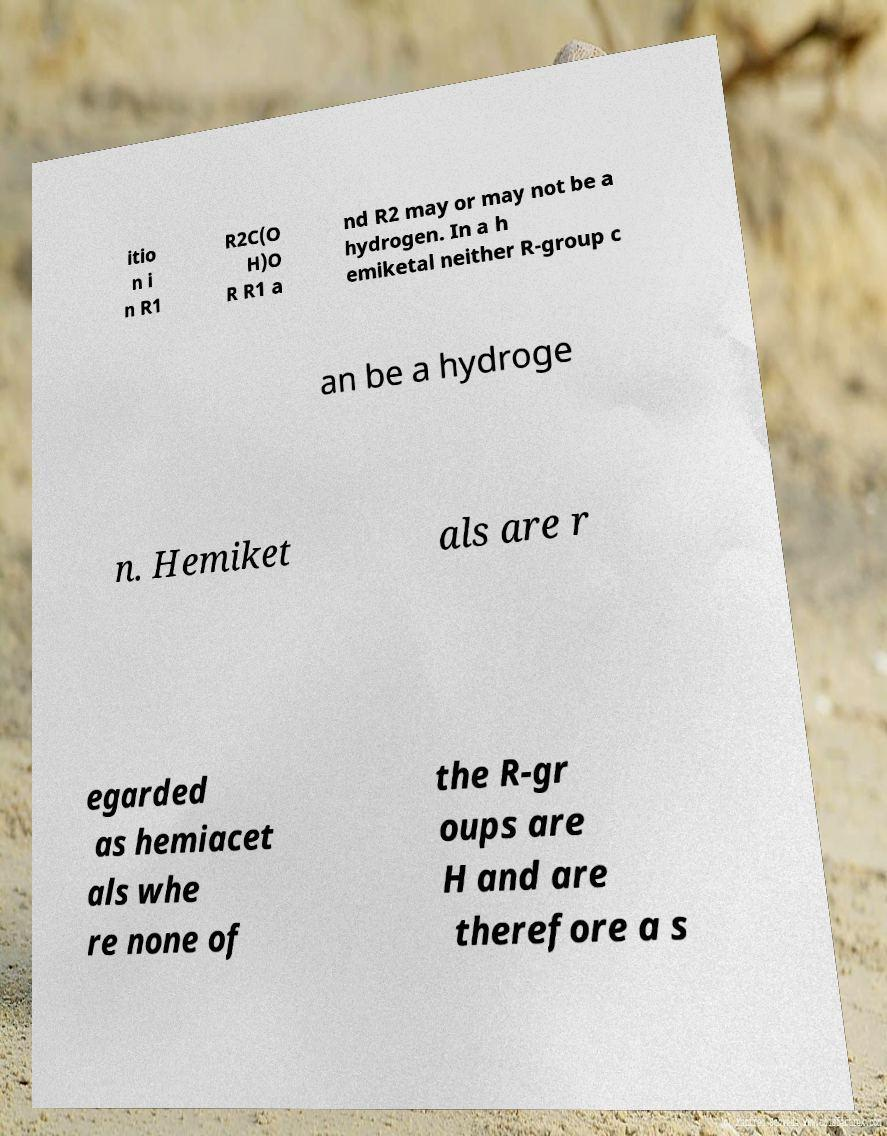What messages or text are displayed in this image? I need them in a readable, typed format. itio n i n R1 R2C(O H)O R R1 a nd R2 may or may not be a hydrogen. In a h emiketal neither R-group c an be a hydroge n. Hemiket als are r egarded as hemiacet als whe re none of the R-gr oups are H and are therefore a s 